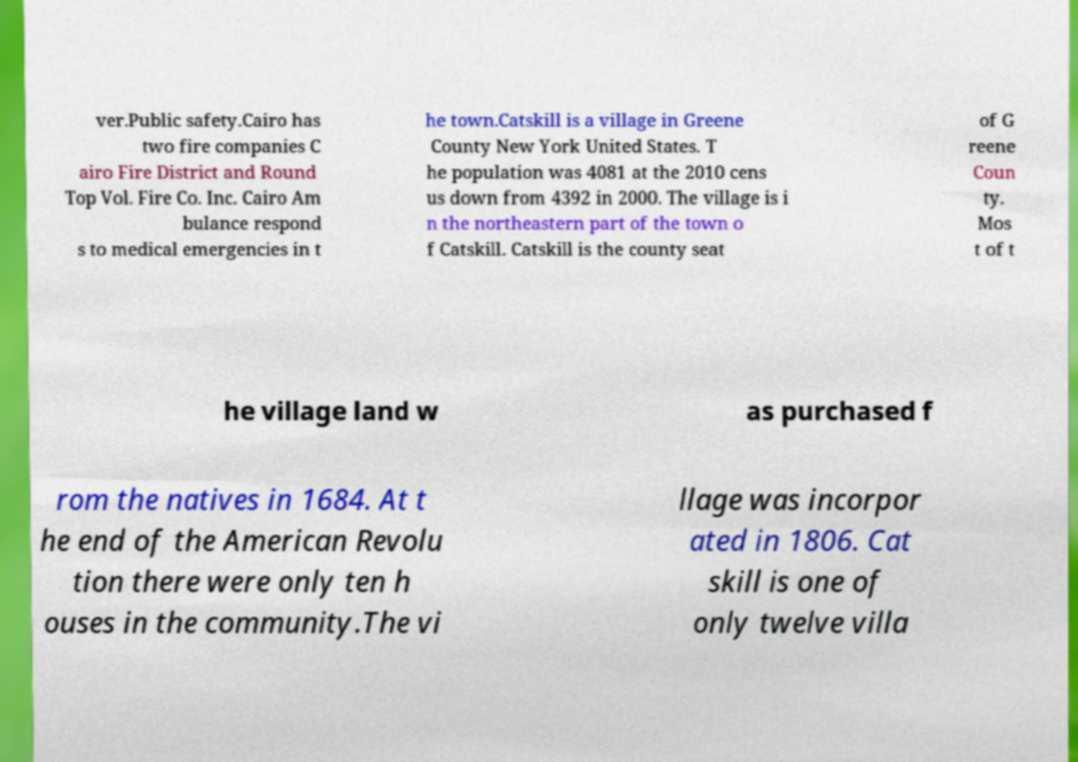Could you extract and type out the text from this image? ver.Public safety.Cairo has two fire companies C airo Fire District and Round Top Vol. Fire Co. Inc. Cairo Am bulance respond s to medical emergencies in t he town.Catskill is a village in Greene County New York United States. T he population was 4081 at the 2010 cens us down from 4392 in 2000. The village is i n the northeastern part of the town o f Catskill. Catskill is the county seat of G reene Coun ty. Mos t of t he village land w as purchased f rom the natives in 1684. At t he end of the American Revolu tion there were only ten h ouses in the community.The vi llage was incorpor ated in 1806. Cat skill is one of only twelve villa 